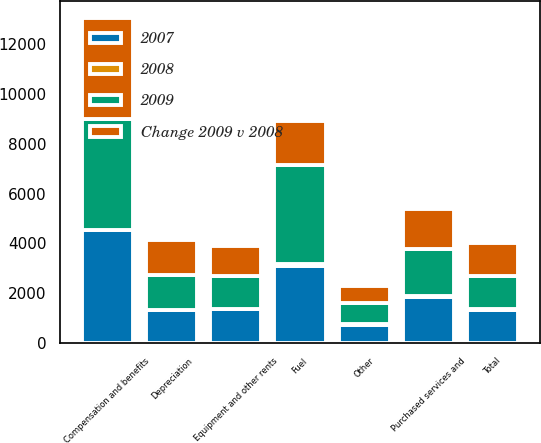<chart> <loc_0><loc_0><loc_500><loc_500><stacked_bar_chart><ecel><fcel>Compensation and benefits<fcel>Fuel<fcel>Purchased services and<fcel>Depreciation<fcel>Equipment and other rents<fcel>Other<fcel>Total<nl><fcel>Change 2009 v 2008<fcel>4063<fcel>1763<fcel>1614<fcel>1444<fcel>1180<fcel>687<fcel>1326<nl><fcel>2009<fcel>4457<fcel>3983<fcel>1902<fcel>1387<fcel>1326<fcel>840<fcel>1326<nl><fcel>2007<fcel>4526<fcel>3104<fcel>1856<fcel>1321<fcel>1368<fcel>733<fcel>1326<nl><fcel>2008<fcel>9<fcel>56<fcel>15<fcel>4<fcel>11<fcel>18<fcel>23<nl></chart> 